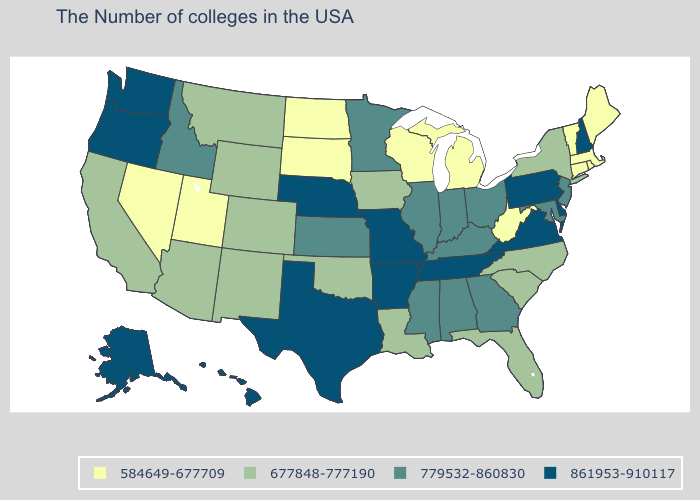What is the value of Maine?
Concise answer only. 584649-677709. Does New Hampshire have the same value as Kansas?
Short answer required. No. Which states have the highest value in the USA?
Write a very short answer. New Hampshire, Delaware, Pennsylvania, Virginia, Tennessee, Missouri, Arkansas, Nebraska, Texas, Washington, Oregon, Alaska, Hawaii. Name the states that have a value in the range 584649-677709?
Give a very brief answer. Maine, Massachusetts, Rhode Island, Vermont, Connecticut, West Virginia, Michigan, Wisconsin, South Dakota, North Dakota, Utah, Nevada. Which states have the lowest value in the Northeast?
Answer briefly. Maine, Massachusetts, Rhode Island, Vermont, Connecticut. Is the legend a continuous bar?
Short answer required. No. Name the states that have a value in the range 861953-910117?
Be succinct. New Hampshire, Delaware, Pennsylvania, Virginia, Tennessee, Missouri, Arkansas, Nebraska, Texas, Washington, Oregon, Alaska, Hawaii. Which states have the lowest value in the USA?
Keep it brief. Maine, Massachusetts, Rhode Island, Vermont, Connecticut, West Virginia, Michigan, Wisconsin, South Dakota, North Dakota, Utah, Nevada. Which states have the highest value in the USA?
Give a very brief answer. New Hampshire, Delaware, Pennsylvania, Virginia, Tennessee, Missouri, Arkansas, Nebraska, Texas, Washington, Oregon, Alaska, Hawaii. Does California have the lowest value in the West?
Give a very brief answer. No. What is the value of Tennessee?
Keep it brief. 861953-910117. What is the lowest value in states that border Iowa?
Quick response, please. 584649-677709. Name the states that have a value in the range 584649-677709?
Keep it brief. Maine, Massachusetts, Rhode Island, Vermont, Connecticut, West Virginia, Michigan, Wisconsin, South Dakota, North Dakota, Utah, Nevada. What is the value of Hawaii?
Short answer required. 861953-910117. 